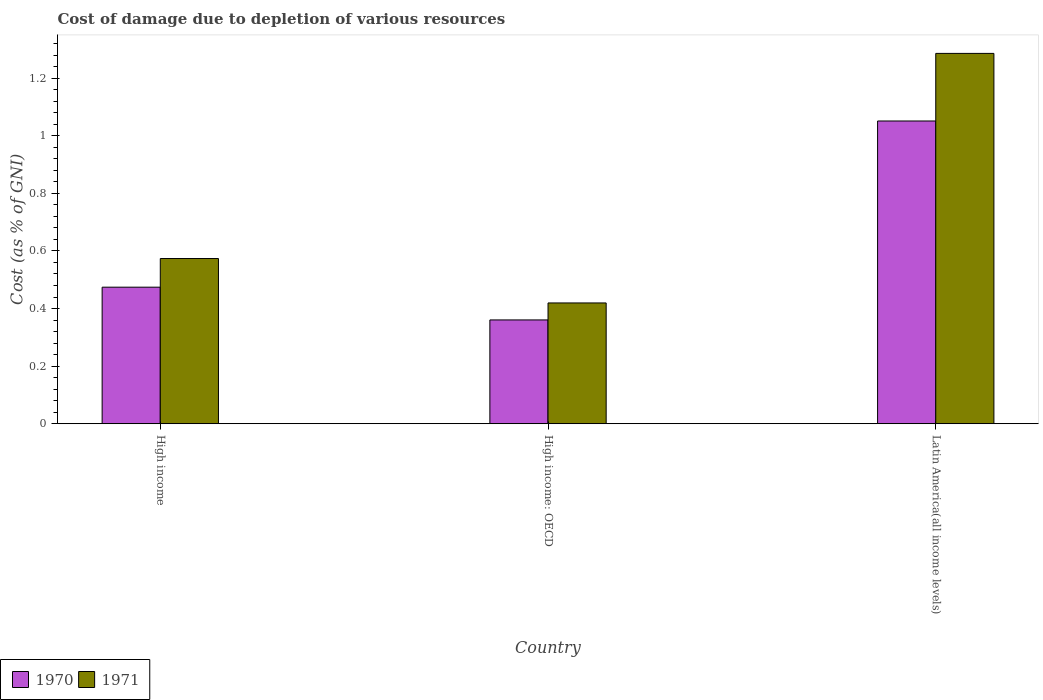How many different coloured bars are there?
Keep it short and to the point. 2. Are the number of bars per tick equal to the number of legend labels?
Provide a succinct answer. Yes. How many bars are there on the 3rd tick from the left?
Ensure brevity in your answer.  2. What is the cost of damage caused due to the depletion of various resources in 1971 in Latin America(all income levels)?
Keep it short and to the point. 1.29. Across all countries, what is the maximum cost of damage caused due to the depletion of various resources in 1971?
Keep it short and to the point. 1.29. Across all countries, what is the minimum cost of damage caused due to the depletion of various resources in 1970?
Give a very brief answer. 0.36. In which country was the cost of damage caused due to the depletion of various resources in 1970 maximum?
Ensure brevity in your answer.  Latin America(all income levels). In which country was the cost of damage caused due to the depletion of various resources in 1971 minimum?
Offer a very short reply. High income: OECD. What is the total cost of damage caused due to the depletion of various resources in 1970 in the graph?
Your answer should be very brief. 1.89. What is the difference between the cost of damage caused due to the depletion of various resources in 1971 in High income and that in Latin America(all income levels)?
Offer a terse response. -0.71. What is the difference between the cost of damage caused due to the depletion of various resources in 1970 in Latin America(all income levels) and the cost of damage caused due to the depletion of various resources in 1971 in High income: OECD?
Offer a terse response. 0.63. What is the average cost of damage caused due to the depletion of various resources in 1970 per country?
Your response must be concise. 0.63. What is the difference between the cost of damage caused due to the depletion of various resources of/in 1971 and cost of damage caused due to the depletion of various resources of/in 1970 in Latin America(all income levels)?
Your response must be concise. 0.23. What is the ratio of the cost of damage caused due to the depletion of various resources in 1970 in High income to that in High income: OECD?
Your answer should be very brief. 1.32. Is the cost of damage caused due to the depletion of various resources in 1970 in High income: OECD less than that in Latin America(all income levels)?
Make the answer very short. Yes. Is the difference between the cost of damage caused due to the depletion of various resources in 1971 in High income and Latin America(all income levels) greater than the difference between the cost of damage caused due to the depletion of various resources in 1970 in High income and Latin America(all income levels)?
Provide a succinct answer. No. What is the difference between the highest and the second highest cost of damage caused due to the depletion of various resources in 1971?
Provide a succinct answer. -0.71. What is the difference between the highest and the lowest cost of damage caused due to the depletion of various resources in 1971?
Offer a terse response. 0.87. In how many countries, is the cost of damage caused due to the depletion of various resources in 1971 greater than the average cost of damage caused due to the depletion of various resources in 1971 taken over all countries?
Provide a short and direct response. 1. How many countries are there in the graph?
Your answer should be compact. 3. Where does the legend appear in the graph?
Keep it short and to the point. Bottom left. What is the title of the graph?
Your response must be concise. Cost of damage due to depletion of various resources. What is the label or title of the X-axis?
Give a very brief answer. Country. What is the label or title of the Y-axis?
Provide a short and direct response. Cost (as % of GNI). What is the Cost (as % of GNI) in 1970 in High income?
Keep it short and to the point. 0.47. What is the Cost (as % of GNI) of 1971 in High income?
Give a very brief answer. 0.57. What is the Cost (as % of GNI) of 1970 in High income: OECD?
Your response must be concise. 0.36. What is the Cost (as % of GNI) in 1971 in High income: OECD?
Keep it short and to the point. 0.42. What is the Cost (as % of GNI) in 1970 in Latin America(all income levels)?
Provide a succinct answer. 1.05. What is the Cost (as % of GNI) in 1971 in Latin America(all income levels)?
Ensure brevity in your answer.  1.29. Across all countries, what is the maximum Cost (as % of GNI) of 1970?
Your response must be concise. 1.05. Across all countries, what is the maximum Cost (as % of GNI) in 1971?
Provide a short and direct response. 1.29. Across all countries, what is the minimum Cost (as % of GNI) of 1970?
Provide a succinct answer. 0.36. Across all countries, what is the minimum Cost (as % of GNI) in 1971?
Make the answer very short. 0.42. What is the total Cost (as % of GNI) in 1970 in the graph?
Ensure brevity in your answer.  1.89. What is the total Cost (as % of GNI) in 1971 in the graph?
Ensure brevity in your answer.  2.28. What is the difference between the Cost (as % of GNI) of 1970 in High income and that in High income: OECD?
Ensure brevity in your answer.  0.11. What is the difference between the Cost (as % of GNI) in 1971 in High income and that in High income: OECD?
Your response must be concise. 0.15. What is the difference between the Cost (as % of GNI) of 1970 in High income and that in Latin America(all income levels)?
Provide a succinct answer. -0.58. What is the difference between the Cost (as % of GNI) of 1971 in High income and that in Latin America(all income levels)?
Make the answer very short. -0.71. What is the difference between the Cost (as % of GNI) of 1970 in High income: OECD and that in Latin America(all income levels)?
Offer a very short reply. -0.69. What is the difference between the Cost (as % of GNI) in 1971 in High income: OECD and that in Latin America(all income levels)?
Your answer should be very brief. -0.87. What is the difference between the Cost (as % of GNI) in 1970 in High income and the Cost (as % of GNI) in 1971 in High income: OECD?
Offer a terse response. 0.05. What is the difference between the Cost (as % of GNI) in 1970 in High income and the Cost (as % of GNI) in 1971 in Latin America(all income levels)?
Make the answer very short. -0.81. What is the difference between the Cost (as % of GNI) of 1970 in High income: OECD and the Cost (as % of GNI) of 1971 in Latin America(all income levels)?
Your answer should be compact. -0.93. What is the average Cost (as % of GNI) in 1970 per country?
Offer a terse response. 0.63. What is the average Cost (as % of GNI) of 1971 per country?
Your answer should be very brief. 0.76. What is the difference between the Cost (as % of GNI) in 1970 and Cost (as % of GNI) in 1971 in High income?
Give a very brief answer. -0.1. What is the difference between the Cost (as % of GNI) in 1970 and Cost (as % of GNI) in 1971 in High income: OECD?
Your response must be concise. -0.06. What is the difference between the Cost (as % of GNI) of 1970 and Cost (as % of GNI) of 1971 in Latin America(all income levels)?
Give a very brief answer. -0.23. What is the ratio of the Cost (as % of GNI) in 1970 in High income to that in High income: OECD?
Offer a very short reply. 1.32. What is the ratio of the Cost (as % of GNI) in 1971 in High income to that in High income: OECD?
Offer a terse response. 1.37. What is the ratio of the Cost (as % of GNI) of 1970 in High income to that in Latin America(all income levels)?
Make the answer very short. 0.45. What is the ratio of the Cost (as % of GNI) of 1971 in High income to that in Latin America(all income levels)?
Your answer should be compact. 0.45. What is the ratio of the Cost (as % of GNI) of 1970 in High income: OECD to that in Latin America(all income levels)?
Make the answer very short. 0.34. What is the ratio of the Cost (as % of GNI) of 1971 in High income: OECD to that in Latin America(all income levels)?
Ensure brevity in your answer.  0.33. What is the difference between the highest and the second highest Cost (as % of GNI) in 1970?
Your response must be concise. 0.58. What is the difference between the highest and the second highest Cost (as % of GNI) of 1971?
Your answer should be compact. 0.71. What is the difference between the highest and the lowest Cost (as % of GNI) in 1970?
Make the answer very short. 0.69. What is the difference between the highest and the lowest Cost (as % of GNI) of 1971?
Make the answer very short. 0.87. 